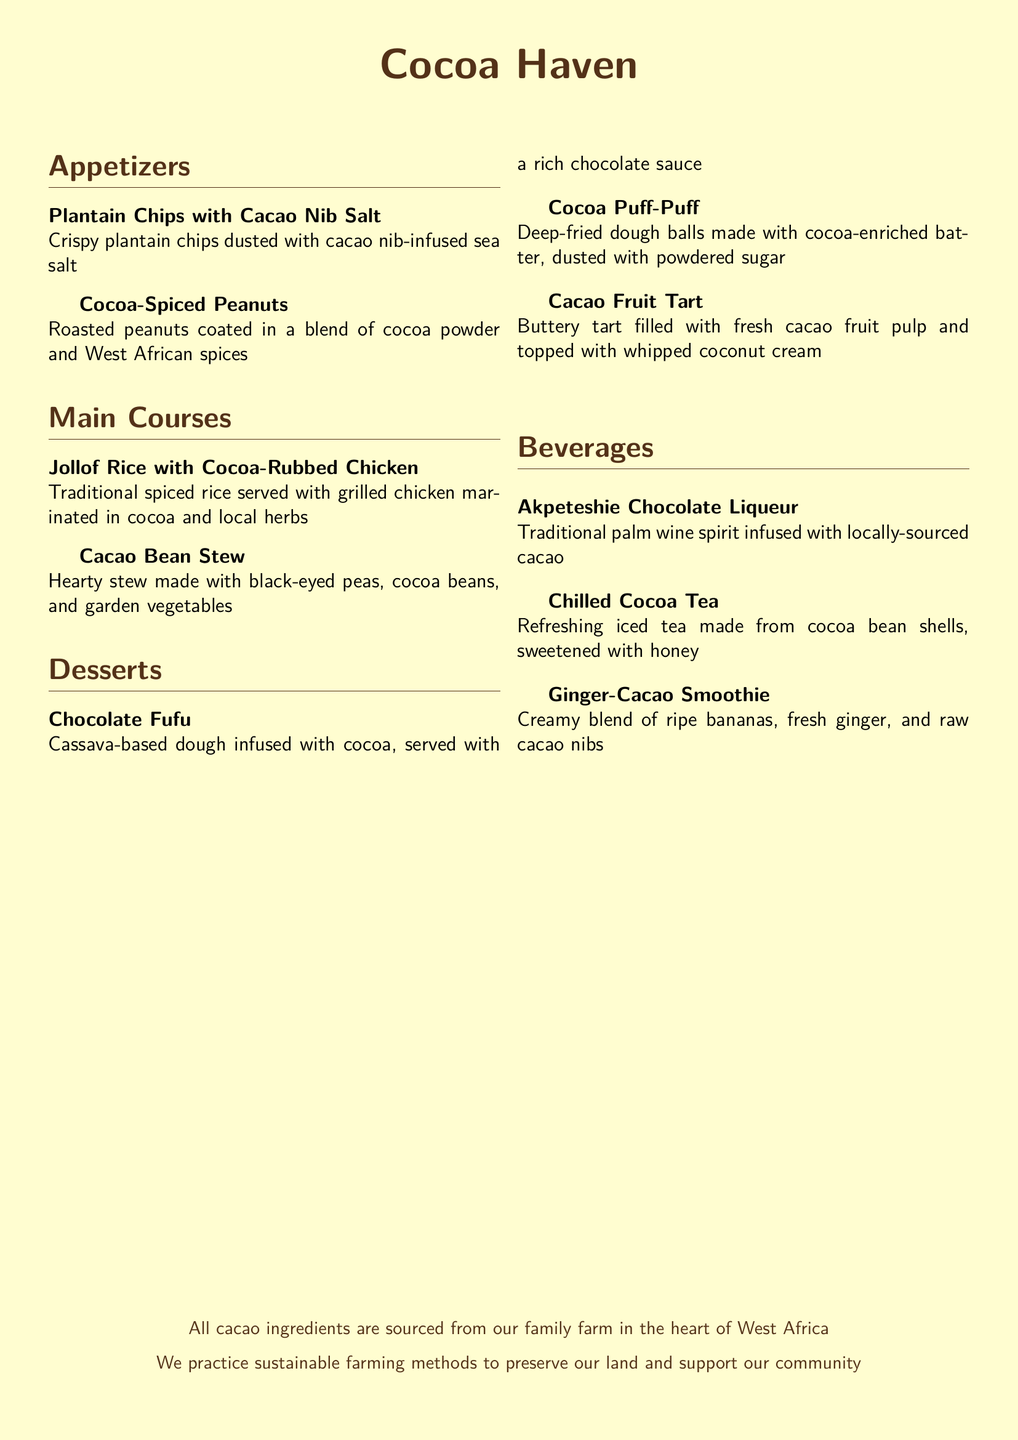what is the name of the restaurant? The title at the top of the menu indicates the name of the restaurant as "Cocoa Haven."
Answer: Cocoa Haven how many appetizers are listed? The menu contains a total of two appetizers.
Answer: 2 what is the main ingredient in Cocoa Puff-Puff? The description specifies that the batter for Cocoa Puff-Puff is cocoa-enriched.
Answer: Cocoa what type of smoothie is offered in the beverages section? The menu includes a beverage called "Ginger-Cacao Smoothie."
Answer: Ginger-Cacao Smoothie what is added to the Chilled Cocoa Tea for sweetness? The description states that honey is used to sweeten the tea.
Answer: Honey how is the Jollof Rice served? The description mentions it is served with grilled chicken marinated in cocoa and local herbs.
Answer: Grilled chicken what is the filling of the Cacao Fruit Tart? The tart is filled with fresh cacao fruit pulp.
Answer: Fresh cacao fruit pulp what color is the page background? The code specifies that the background color of the page is cream.
Answer: Cream what is the source of the cacao ingredients? The note at the bottom of the menu states that all cacao ingredients are sourced from their family farm.
Answer: Family farm 